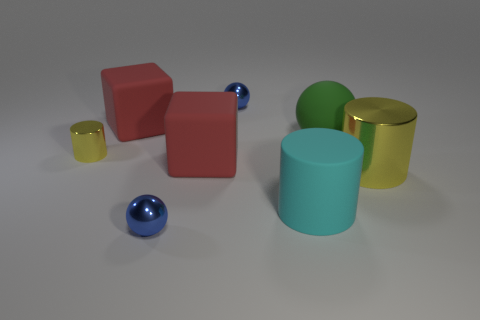The thing that is in front of the matte ball and to the right of the large cyan matte cylinder has what shape?
Ensure brevity in your answer.  Cylinder. Is the number of red rubber cubes left of the big yellow metal cylinder less than the number of big green rubber spheres?
Make the answer very short. No. What number of big things are metal cylinders or gray balls?
Your answer should be very brief. 1. The cyan matte cylinder has what size?
Your answer should be very brief. Large. Are there any other things that are the same material as the big green ball?
Ensure brevity in your answer.  Yes. There is a big yellow cylinder; how many things are behind it?
Provide a short and direct response. 5. What size is the other matte thing that is the same shape as the tiny yellow thing?
Your response must be concise. Large. What size is the cylinder that is both in front of the tiny yellow cylinder and behind the cyan matte object?
Provide a short and direct response. Large. There is a rubber ball; does it have the same color as the small object that is in front of the small yellow thing?
Your answer should be compact. No. What number of blue things are big shiny cylinders or large cylinders?
Ensure brevity in your answer.  0. 